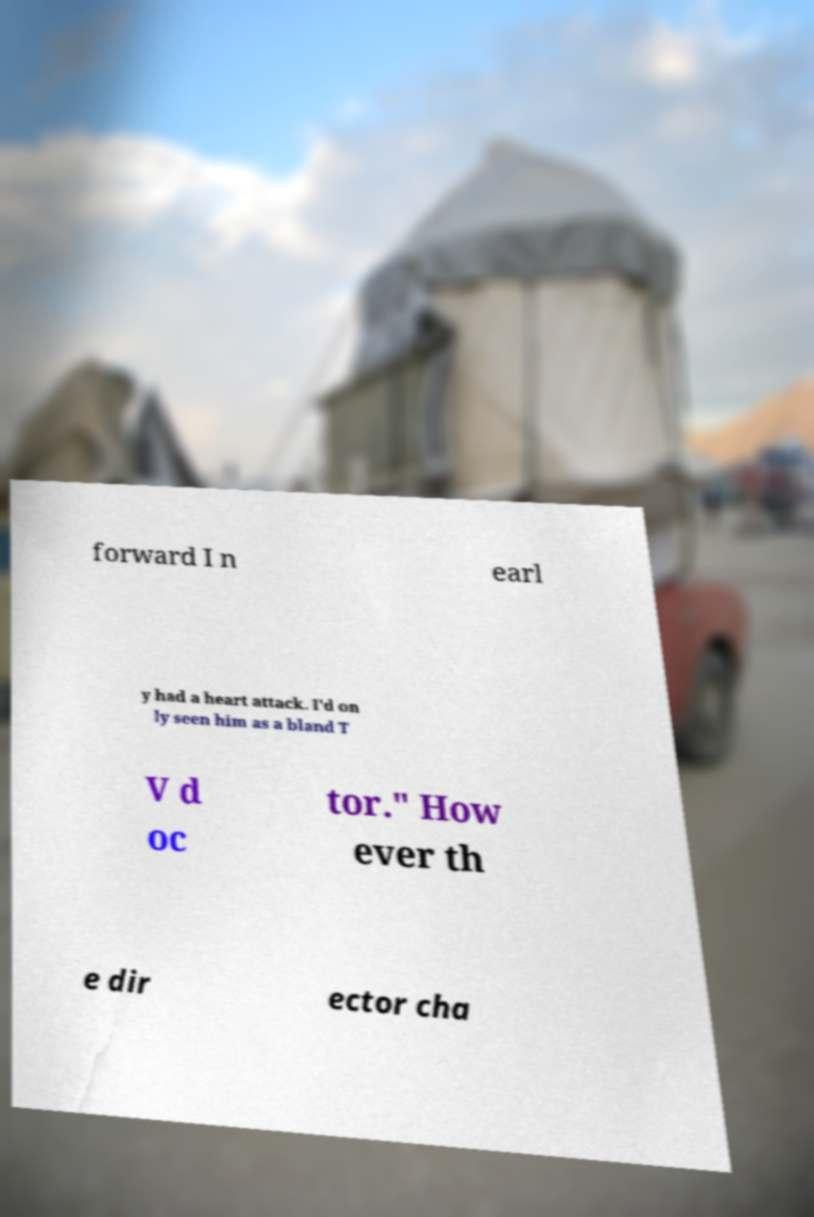Could you extract and type out the text from this image? forward I n earl y had a heart attack. I'd on ly seen him as a bland T V d oc tor." How ever th e dir ector cha 